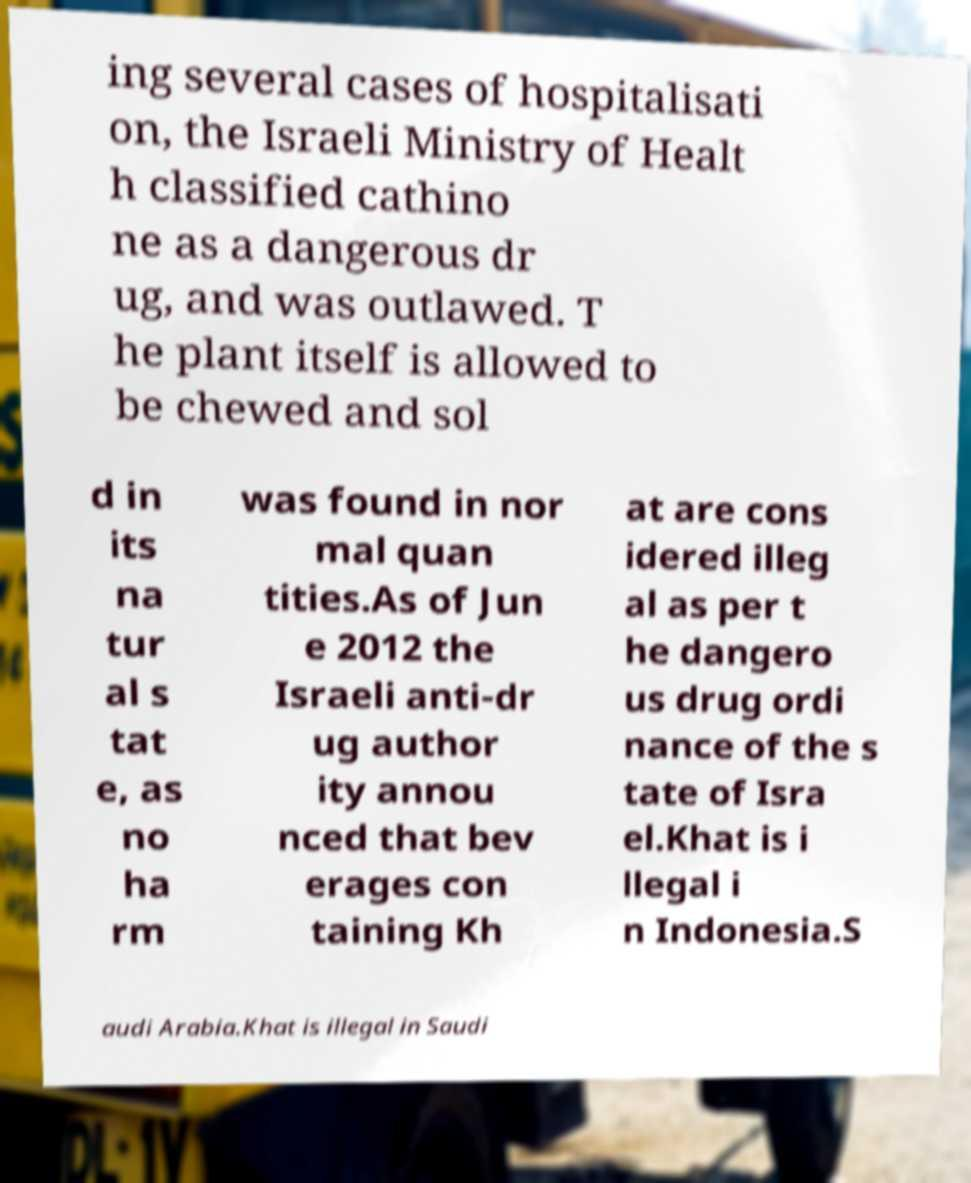For documentation purposes, I need the text within this image transcribed. Could you provide that? ing several cases of hospitalisati on, the Israeli Ministry of Healt h classified cathino ne as a dangerous dr ug, and was outlawed. T he plant itself is allowed to be chewed and sol d in its na tur al s tat e, as no ha rm was found in nor mal quan tities.As of Jun e 2012 the Israeli anti-dr ug author ity annou nced that bev erages con taining Kh at are cons idered illeg al as per t he dangero us drug ordi nance of the s tate of Isra el.Khat is i llegal i n Indonesia.S audi Arabia.Khat is illegal in Saudi 